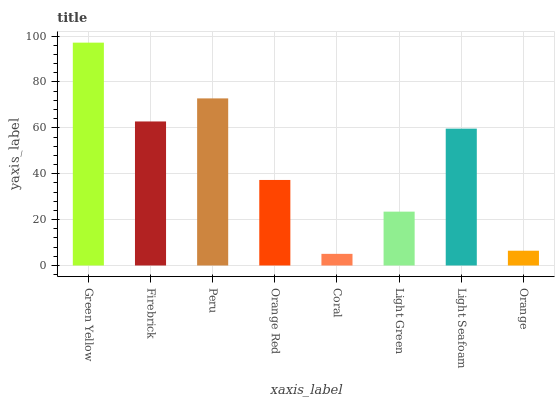Is Coral the minimum?
Answer yes or no. Yes. Is Green Yellow the maximum?
Answer yes or no. Yes. Is Firebrick the minimum?
Answer yes or no. No. Is Firebrick the maximum?
Answer yes or no. No. Is Green Yellow greater than Firebrick?
Answer yes or no. Yes. Is Firebrick less than Green Yellow?
Answer yes or no. Yes. Is Firebrick greater than Green Yellow?
Answer yes or no. No. Is Green Yellow less than Firebrick?
Answer yes or no. No. Is Light Seafoam the high median?
Answer yes or no. Yes. Is Orange Red the low median?
Answer yes or no. Yes. Is Light Green the high median?
Answer yes or no. No. Is Orange the low median?
Answer yes or no. No. 